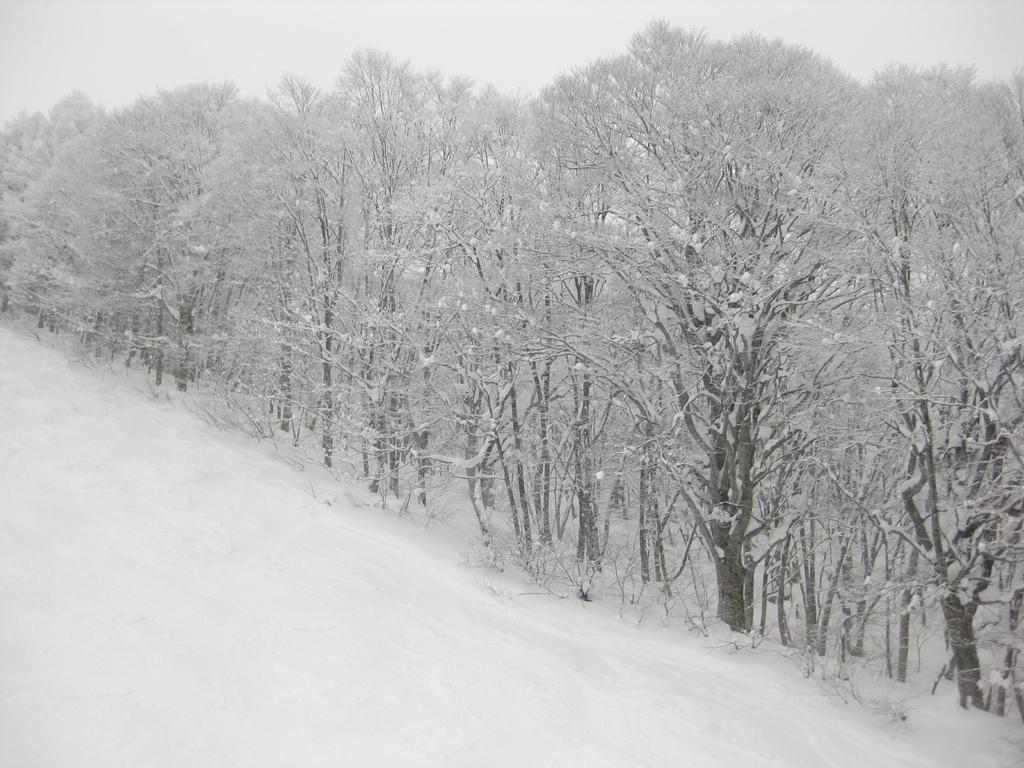What is the main feature of the image? The main feature of the image is snow. What else can be seen in the image besides snow? There are trees covered with snow in the image. What can be seen in the background of the image? There is a sky visible in the background of the image. What type of war is being depicted in the image? There is no war being depicted in the image; it features snow and trees covered with snow. Can you tell me how many geese are visible in the image? There are no geese present in the image; it features snow and trees covered with snow. 